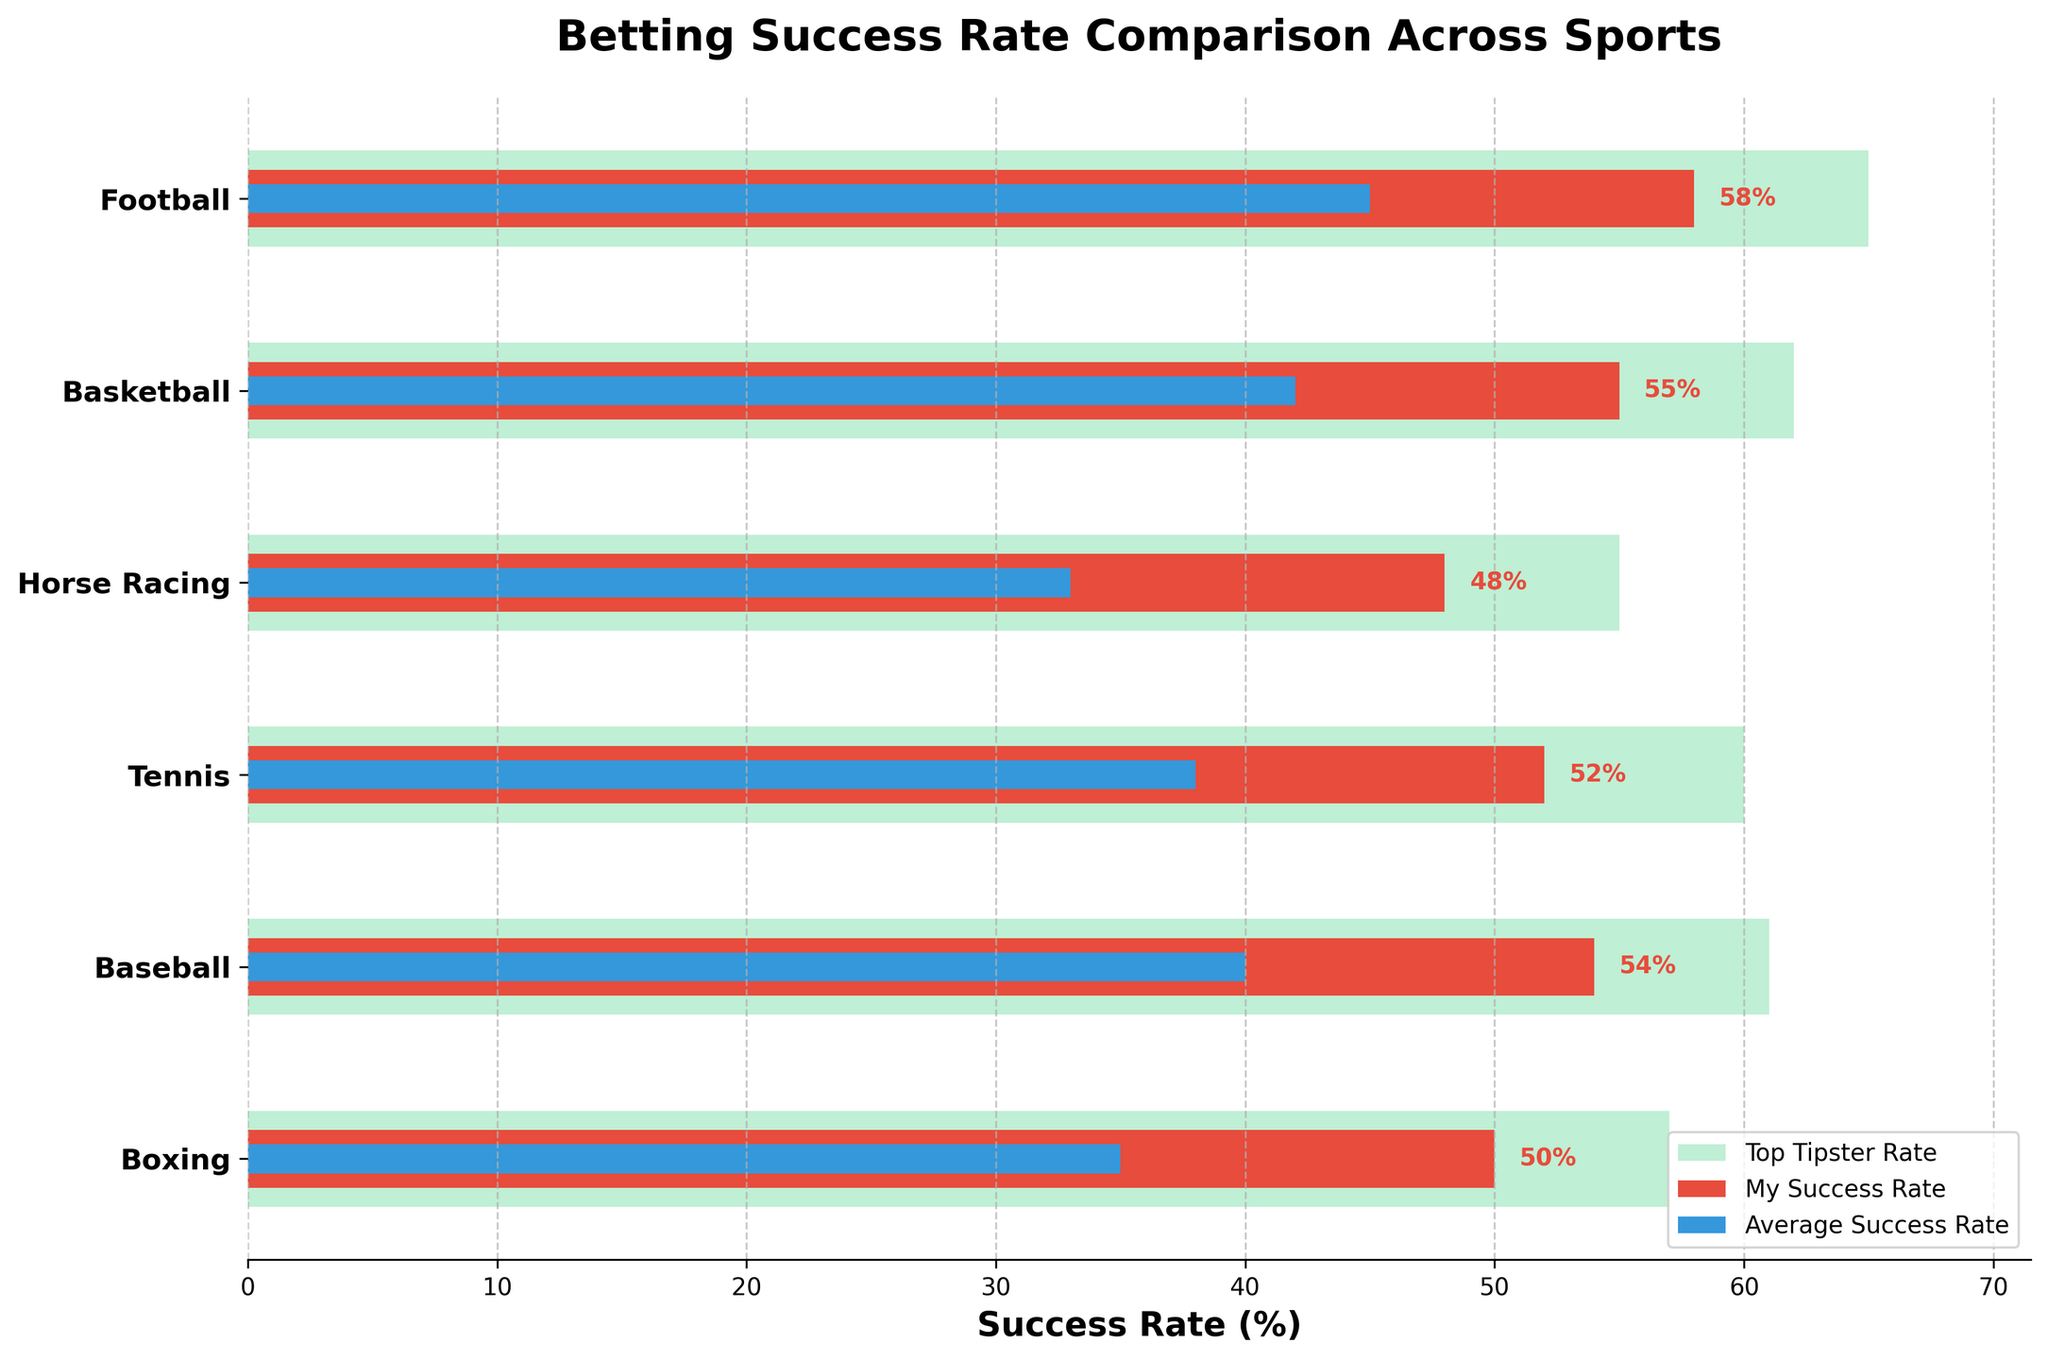What's the title of the plot? The title is prominently displayed at the top of the chart, indicating what the chart represents. It helps in understanding the overall context of the data.
Answer: Betting Success Rate Comparison Across Sports Which sport has the highest success rate for the top tipster? By examining the lengths of the green bars, which represent the top tipster rates, the longest bar corresponds to Football at 65%.
Answer: Football How does my success rate for Tennis compare to the average success rate for that sport? Locate Tennis on the y-axis, then compare the red bar (my success rate) with the blue bar (average success rate). My success rate is 52%, whereas the average success rate is 38%.
Answer: 52% vs 38% Which sport shows the greatest difference between my success rate and the top tipster rate? Calculate the differences between the red and green bars for each sport. The greatest difference is seen in Horse Racing, where my success rate is 48%, and the top tipster’s success rate is 55%, a difference of 7%.
Answer: Horse Racing What is the average success rate across all sports? Sum the average success rates (45 + 42 + 33 + 38 + 40 + 35) and divide by the number of sports (6). The sum is 233, and the average is 233/6 ≈ 38.8%.
Answer: 38.8% Which sport has the smallest gap between my success rate and the average success rate? Calculate the differences for each sport and identify the smallest one. For Basketball, the difference is 55% - 42% = 13%, which is the smallest gap.
Answer: Basketball How does my success rate in Baseball compare to that in Basketball? Compare the lengths of the red bars for Baseball and Basketball. For Baseball, my success rate is 54%, and for Basketball, it is 55%.
Answer: 54% vs 55% What is the overall trend in my success rates across the various sports? By visually assessing the red bars, it can be observed that my success rates are consistently higher than the average for all sports, showing a trend of above-average performance.
Answer: Above-average performance How many sports have a top tipster success rate above 60%? Count the number of sports where the green bar exceeds the 60% mark. These sports are Football, Basketball, Tennis, and Baseball, totaling 4.
Answer: 4 Is there any sport where my success rate is lower than the average success rate? By comparing the red and blue bars for all sports, it is evident that in all cases, my success rate (red) is higher than the average success rate (blue).
Answer: No 